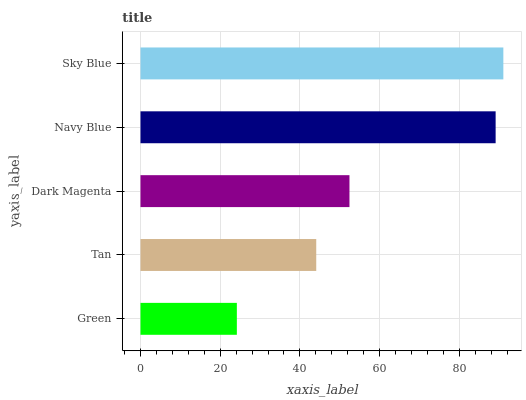Is Green the minimum?
Answer yes or no. Yes. Is Sky Blue the maximum?
Answer yes or no. Yes. Is Tan the minimum?
Answer yes or no. No. Is Tan the maximum?
Answer yes or no. No. Is Tan greater than Green?
Answer yes or no. Yes. Is Green less than Tan?
Answer yes or no. Yes. Is Green greater than Tan?
Answer yes or no. No. Is Tan less than Green?
Answer yes or no. No. Is Dark Magenta the high median?
Answer yes or no. Yes. Is Dark Magenta the low median?
Answer yes or no. Yes. Is Green the high median?
Answer yes or no. No. Is Tan the low median?
Answer yes or no. No. 